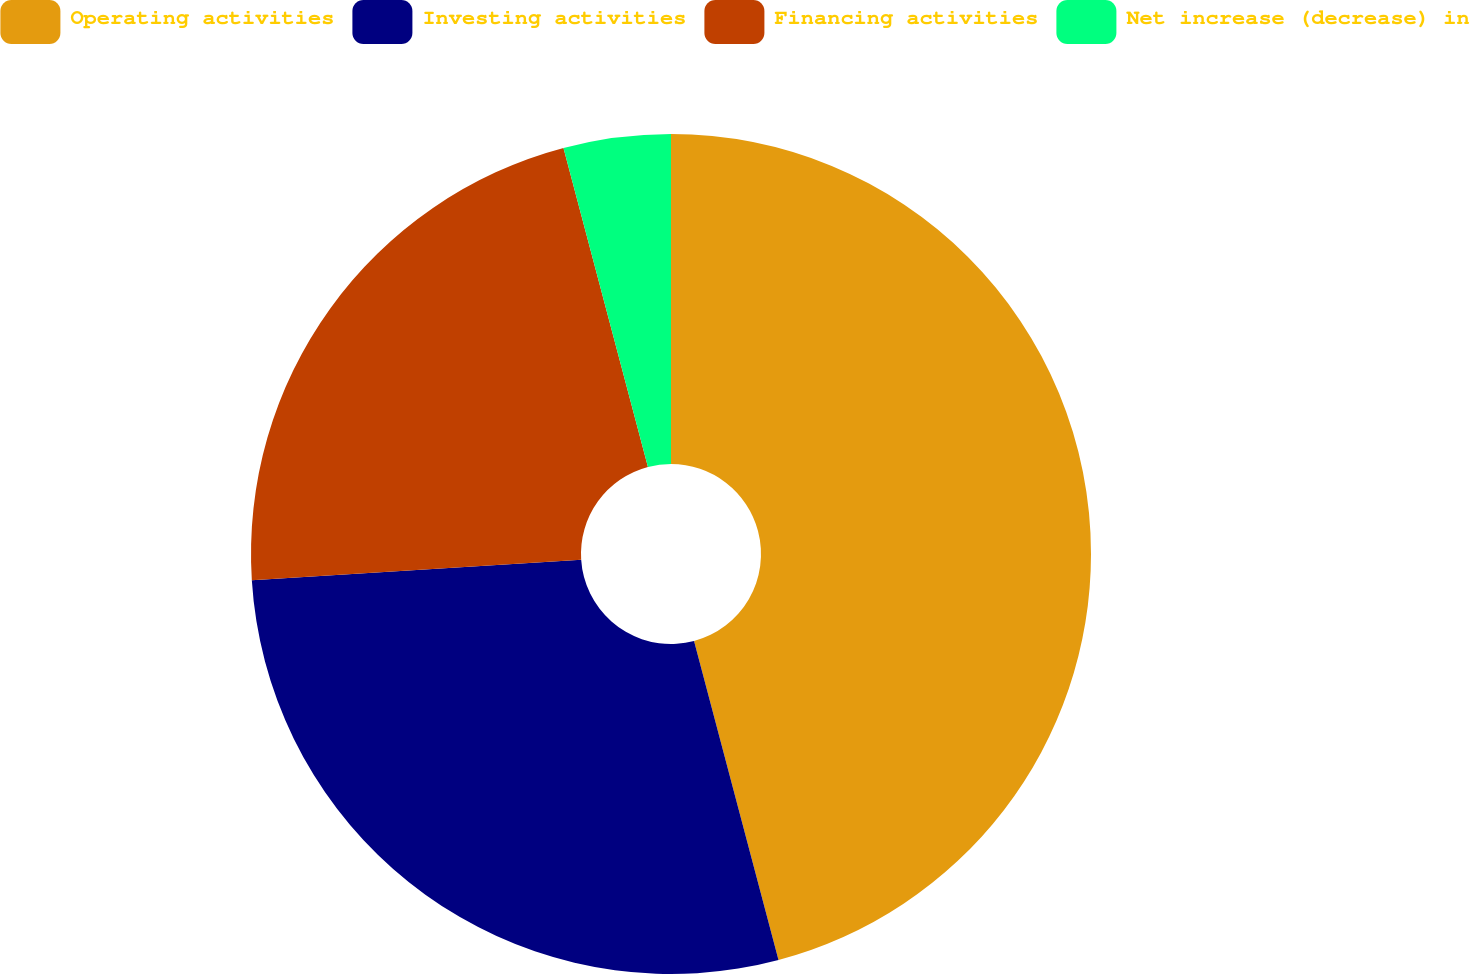<chart> <loc_0><loc_0><loc_500><loc_500><pie_chart><fcel>Operating activities<fcel>Investing activities<fcel>Financing activities<fcel>Net increase (decrease) in<nl><fcel>45.88%<fcel>28.12%<fcel>21.88%<fcel>4.12%<nl></chart> 